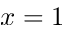Convert formula to latex. <formula><loc_0><loc_0><loc_500><loc_500>x = 1</formula> 